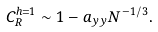Convert formula to latex. <formula><loc_0><loc_0><loc_500><loc_500>C _ { R } ^ { h = 1 } \sim 1 - a _ { y y } N ^ { - 1 / 3 } .</formula> 